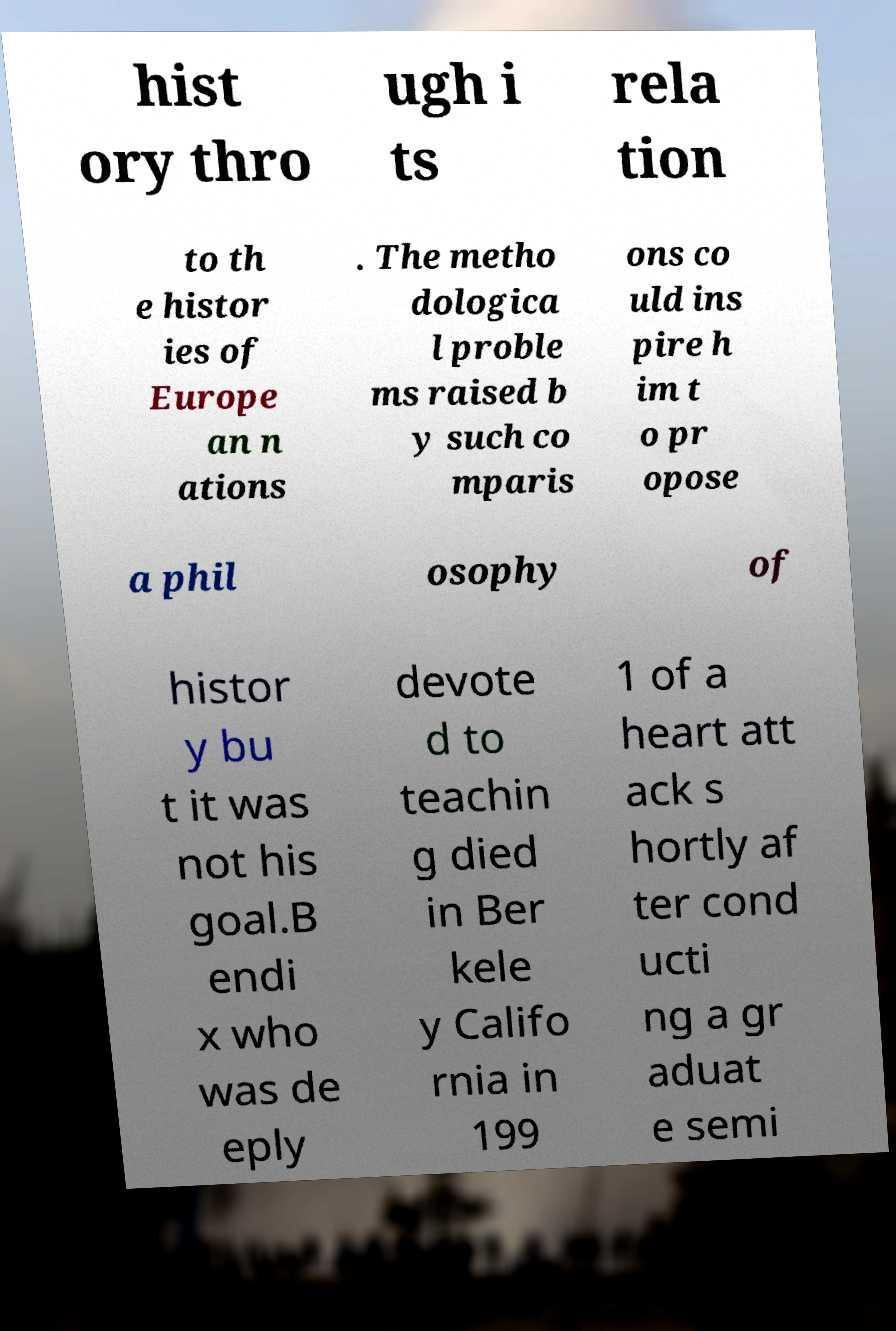For documentation purposes, I need the text within this image transcribed. Could you provide that? hist ory thro ugh i ts rela tion to th e histor ies of Europe an n ations . The metho dologica l proble ms raised b y such co mparis ons co uld ins pire h im t o pr opose a phil osophy of histor y bu t it was not his goal.B endi x who was de eply devote d to teachin g died in Ber kele y Califo rnia in 199 1 of a heart att ack s hortly af ter cond ucti ng a gr aduat e semi 